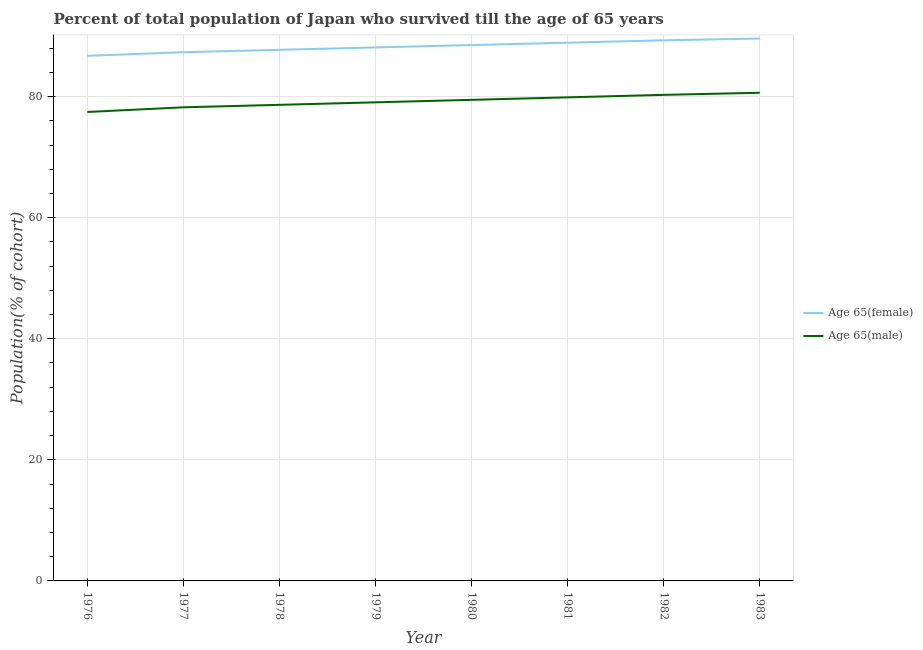How many different coloured lines are there?
Ensure brevity in your answer.  2. What is the percentage of female population who survived till age of 65 in 1976?
Provide a succinct answer. 86.73. Across all years, what is the maximum percentage of male population who survived till age of 65?
Provide a short and direct response. 80.63. Across all years, what is the minimum percentage of male population who survived till age of 65?
Keep it short and to the point. 77.46. In which year was the percentage of female population who survived till age of 65 minimum?
Your response must be concise. 1976. What is the total percentage of male population who survived till age of 65 in the graph?
Your answer should be very brief. 633.63. What is the difference between the percentage of female population who survived till age of 65 in 1980 and that in 1981?
Ensure brevity in your answer.  -0.39. What is the difference between the percentage of female population who survived till age of 65 in 1979 and the percentage of male population who survived till age of 65 in 1982?
Offer a terse response. 7.83. What is the average percentage of male population who survived till age of 65 per year?
Ensure brevity in your answer.  79.2. In the year 1979, what is the difference between the percentage of female population who survived till age of 65 and percentage of male population who survived till age of 65?
Ensure brevity in your answer.  9.07. In how many years, is the percentage of male population who survived till age of 65 greater than 8 %?
Your answer should be very brief. 8. What is the ratio of the percentage of female population who survived till age of 65 in 1979 to that in 1982?
Your answer should be compact. 0.99. What is the difference between the highest and the second highest percentage of male population who survived till age of 65?
Offer a very short reply. 0.35. What is the difference between the highest and the lowest percentage of male population who survived till age of 65?
Provide a short and direct response. 3.17. In how many years, is the percentage of female population who survived till age of 65 greater than the average percentage of female population who survived till age of 65 taken over all years?
Your response must be concise. 4. Is the sum of the percentage of female population who survived till age of 65 in 1980 and 1981 greater than the maximum percentage of male population who survived till age of 65 across all years?
Offer a terse response. Yes. Does the percentage of male population who survived till age of 65 monotonically increase over the years?
Your answer should be compact. Yes. Is the percentage of male population who survived till age of 65 strictly less than the percentage of female population who survived till age of 65 over the years?
Your answer should be compact. Yes. How many lines are there?
Your answer should be compact. 2. How many years are there in the graph?
Offer a very short reply. 8. Are the values on the major ticks of Y-axis written in scientific E-notation?
Offer a very short reply. No. How are the legend labels stacked?
Ensure brevity in your answer.  Vertical. What is the title of the graph?
Offer a terse response. Percent of total population of Japan who survived till the age of 65 years. What is the label or title of the Y-axis?
Provide a succinct answer. Population(% of cohort). What is the Population(% of cohort) of Age 65(female) in 1976?
Offer a terse response. 86.73. What is the Population(% of cohort) of Age 65(male) in 1976?
Ensure brevity in your answer.  77.46. What is the Population(% of cohort) of Age 65(female) in 1977?
Provide a short and direct response. 87.33. What is the Population(% of cohort) in Age 65(male) in 1977?
Provide a short and direct response. 78.23. What is the Population(% of cohort) of Age 65(female) in 1978?
Your response must be concise. 87.72. What is the Population(% of cohort) of Age 65(male) in 1978?
Keep it short and to the point. 78.64. What is the Population(% of cohort) of Age 65(female) in 1979?
Give a very brief answer. 88.12. What is the Population(% of cohort) of Age 65(male) in 1979?
Your answer should be compact. 79.05. What is the Population(% of cohort) of Age 65(female) in 1980?
Offer a terse response. 88.51. What is the Population(% of cohort) in Age 65(male) in 1980?
Offer a terse response. 79.46. What is the Population(% of cohort) of Age 65(female) in 1981?
Make the answer very short. 88.9. What is the Population(% of cohort) of Age 65(male) in 1981?
Your answer should be compact. 79.87. What is the Population(% of cohort) of Age 65(female) in 1982?
Provide a short and direct response. 89.3. What is the Population(% of cohort) of Age 65(male) in 1982?
Keep it short and to the point. 80.29. What is the Population(% of cohort) in Age 65(female) in 1983?
Ensure brevity in your answer.  89.59. What is the Population(% of cohort) of Age 65(male) in 1983?
Keep it short and to the point. 80.63. Across all years, what is the maximum Population(% of cohort) of Age 65(female)?
Provide a short and direct response. 89.59. Across all years, what is the maximum Population(% of cohort) of Age 65(male)?
Offer a very short reply. 80.63. Across all years, what is the minimum Population(% of cohort) in Age 65(female)?
Ensure brevity in your answer.  86.73. Across all years, what is the minimum Population(% of cohort) in Age 65(male)?
Your answer should be compact. 77.46. What is the total Population(% of cohort) of Age 65(female) in the graph?
Provide a short and direct response. 706.2. What is the total Population(% of cohort) in Age 65(male) in the graph?
Ensure brevity in your answer.  633.63. What is the difference between the Population(% of cohort) in Age 65(female) in 1976 and that in 1977?
Give a very brief answer. -0.6. What is the difference between the Population(% of cohort) of Age 65(male) in 1976 and that in 1977?
Provide a short and direct response. -0.77. What is the difference between the Population(% of cohort) of Age 65(female) in 1976 and that in 1978?
Provide a short and direct response. -1. What is the difference between the Population(% of cohort) in Age 65(male) in 1976 and that in 1978?
Your answer should be compact. -1.18. What is the difference between the Population(% of cohort) of Age 65(female) in 1976 and that in 1979?
Your answer should be very brief. -1.39. What is the difference between the Population(% of cohort) of Age 65(male) in 1976 and that in 1979?
Your answer should be very brief. -1.59. What is the difference between the Population(% of cohort) in Age 65(female) in 1976 and that in 1980?
Your answer should be very brief. -1.78. What is the difference between the Population(% of cohort) in Age 65(male) in 1976 and that in 1980?
Provide a short and direct response. -2. What is the difference between the Population(% of cohort) in Age 65(female) in 1976 and that in 1981?
Give a very brief answer. -2.18. What is the difference between the Population(% of cohort) of Age 65(male) in 1976 and that in 1981?
Keep it short and to the point. -2.42. What is the difference between the Population(% of cohort) in Age 65(female) in 1976 and that in 1982?
Your response must be concise. -2.57. What is the difference between the Population(% of cohort) of Age 65(male) in 1976 and that in 1982?
Make the answer very short. -2.83. What is the difference between the Population(% of cohort) in Age 65(female) in 1976 and that in 1983?
Your answer should be very brief. -2.86. What is the difference between the Population(% of cohort) in Age 65(male) in 1976 and that in 1983?
Your answer should be very brief. -3.17. What is the difference between the Population(% of cohort) of Age 65(female) in 1977 and that in 1978?
Keep it short and to the point. -0.39. What is the difference between the Population(% of cohort) in Age 65(male) in 1977 and that in 1978?
Provide a short and direct response. -0.41. What is the difference between the Population(% of cohort) of Age 65(female) in 1977 and that in 1979?
Provide a short and direct response. -0.79. What is the difference between the Population(% of cohort) in Age 65(male) in 1977 and that in 1979?
Give a very brief answer. -0.82. What is the difference between the Population(% of cohort) of Age 65(female) in 1977 and that in 1980?
Your answer should be very brief. -1.18. What is the difference between the Population(% of cohort) in Age 65(male) in 1977 and that in 1980?
Give a very brief answer. -1.24. What is the difference between the Population(% of cohort) of Age 65(female) in 1977 and that in 1981?
Your answer should be very brief. -1.57. What is the difference between the Population(% of cohort) of Age 65(male) in 1977 and that in 1981?
Give a very brief answer. -1.65. What is the difference between the Population(% of cohort) of Age 65(female) in 1977 and that in 1982?
Make the answer very short. -1.97. What is the difference between the Population(% of cohort) in Age 65(male) in 1977 and that in 1982?
Your answer should be very brief. -2.06. What is the difference between the Population(% of cohort) of Age 65(female) in 1977 and that in 1983?
Your answer should be compact. -2.25. What is the difference between the Population(% of cohort) in Age 65(male) in 1977 and that in 1983?
Provide a succinct answer. -2.41. What is the difference between the Population(% of cohort) in Age 65(female) in 1978 and that in 1979?
Your answer should be very brief. -0.39. What is the difference between the Population(% of cohort) of Age 65(male) in 1978 and that in 1979?
Make the answer very short. -0.41. What is the difference between the Population(% of cohort) of Age 65(female) in 1978 and that in 1980?
Your answer should be very brief. -0.79. What is the difference between the Population(% of cohort) in Age 65(male) in 1978 and that in 1980?
Your answer should be very brief. -0.82. What is the difference between the Population(% of cohort) of Age 65(female) in 1978 and that in 1981?
Offer a terse response. -1.18. What is the difference between the Population(% of cohort) in Age 65(male) in 1978 and that in 1981?
Offer a very short reply. -1.24. What is the difference between the Population(% of cohort) in Age 65(female) in 1978 and that in 1982?
Provide a succinct answer. -1.57. What is the difference between the Population(% of cohort) in Age 65(male) in 1978 and that in 1982?
Your response must be concise. -1.65. What is the difference between the Population(% of cohort) in Age 65(female) in 1978 and that in 1983?
Offer a very short reply. -1.86. What is the difference between the Population(% of cohort) of Age 65(male) in 1978 and that in 1983?
Keep it short and to the point. -2. What is the difference between the Population(% of cohort) of Age 65(female) in 1979 and that in 1980?
Your answer should be compact. -0.39. What is the difference between the Population(% of cohort) of Age 65(male) in 1979 and that in 1980?
Provide a short and direct response. -0.41. What is the difference between the Population(% of cohort) in Age 65(female) in 1979 and that in 1981?
Provide a succinct answer. -0.79. What is the difference between the Population(% of cohort) of Age 65(male) in 1979 and that in 1981?
Your answer should be very brief. -0.82. What is the difference between the Population(% of cohort) of Age 65(female) in 1979 and that in 1982?
Your response must be concise. -1.18. What is the difference between the Population(% of cohort) in Age 65(male) in 1979 and that in 1982?
Offer a terse response. -1.24. What is the difference between the Population(% of cohort) of Age 65(female) in 1979 and that in 1983?
Your answer should be compact. -1.47. What is the difference between the Population(% of cohort) of Age 65(male) in 1979 and that in 1983?
Provide a short and direct response. -1.58. What is the difference between the Population(% of cohort) of Age 65(female) in 1980 and that in 1981?
Provide a succinct answer. -0.39. What is the difference between the Population(% of cohort) of Age 65(male) in 1980 and that in 1981?
Give a very brief answer. -0.41. What is the difference between the Population(% of cohort) in Age 65(female) in 1980 and that in 1982?
Make the answer very short. -0.79. What is the difference between the Population(% of cohort) of Age 65(male) in 1980 and that in 1982?
Your response must be concise. -0.82. What is the difference between the Population(% of cohort) of Age 65(female) in 1980 and that in 1983?
Make the answer very short. -1.07. What is the difference between the Population(% of cohort) in Age 65(male) in 1980 and that in 1983?
Your answer should be very brief. -1.17. What is the difference between the Population(% of cohort) of Age 65(female) in 1981 and that in 1982?
Offer a terse response. -0.39. What is the difference between the Population(% of cohort) of Age 65(male) in 1981 and that in 1982?
Your response must be concise. -0.41. What is the difference between the Population(% of cohort) of Age 65(female) in 1981 and that in 1983?
Offer a terse response. -0.68. What is the difference between the Population(% of cohort) of Age 65(male) in 1981 and that in 1983?
Offer a very short reply. -0.76. What is the difference between the Population(% of cohort) of Age 65(female) in 1982 and that in 1983?
Ensure brevity in your answer.  -0.29. What is the difference between the Population(% of cohort) of Age 65(male) in 1982 and that in 1983?
Your answer should be compact. -0.35. What is the difference between the Population(% of cohort) of Age 65(female) in 1976 and the Population(% of cohort) of Age 65(male) in 1977?
Ensure brevity in your answer.  8.5. What is the difference between the Population(% of cohort) of Age 65(female) in 1976 and the Population(% of cohort) of Age 65(male) in 1978?
Give a very brief answer. 8.09. What is the difference between the Population(% of cohort) in Age 65(female) in 1976 and the Population(% of cohort) in Age 65(male) in 1979?
Your response must be concise. 7.68. What is the difference between the Population(% of cohort) of Age 65(female) in 1976 and the Population(% of cohort) of Age 65(male) in 1980?
Your answer should be compact. 7.27. What is the difference between the Population(% of cohort) of Age 65(female) in 1976 and the Population(% of cohort) of Age 65(male) in 1981?
Ensure brevity in your answer.  6.85. What is the difference between the Population(% of cohort) of Age 65(female) in 1976 and the Population(% of cohort) of Age 65(male) in 1982?
Your answer should be compact. 6.44. What is the difference between the Population(% of cohort) in Age 65(female) in 1976 and the Population(% of cohort) in Age 65(male) in 1983?
Keep it short and to the point. 6.09. What is the difference between the Population(% of cohort) in Age 65(female) in 1977 and the Population(% of cohort) in Age 65(male) in 1978?
Provide a succinct answer. 8.69. What is the difference between the Population(% of cohort) of Age 65(female) in 1977 and the Population(% of cohort) of Age 65(male) in 1979?
Offer a terse response. 8.28. What is the difference between the Population(% of cohort) of Age 65(female) in 1977 and the Population(% of cohort) of Age 65(male) in 1980?
Your answer should be very brief. 7.87. What is the difference between the Population(% of cohort) of Age 65(female) in 1977 and the Population(% of cohort) of Age 65(male) in 1981?
Offer a terse response. 7.46. What is the difference between the Population(% of cohort) in Age 65(female) in 1977 and the Population(% of cohort) in Age 65(male) in 1982?
Provide a short and direct response. 7.05. What is the difference between the Population(% of cohort) of Age 65(female) in 1977 and the Population(% of cohort) of Age 65(male) in 1983?
Keep it short and to the point. 6.7. What is the difference between the Population(% of cohort) in Age 65(female) in 1978 and the Population(% of cohort) in Age 65(male) in 1979?
Offer a terse response. 8.67. What is the difference between the Population(% of cohort) of Age 65(female) in 1978 and the Population(% of cohort) of Age 65(male) in 1980?
Offer a very short reply. 8.26. What is the difference between the Population(% of cohort) of Age 65(female) in 1978 and the Population(% of cohort) of Age 65(male) in 1981?
Offer a terse response. 7.85. What is the difference between the Population(% of cohort) of Age 65(female) in 1978 and the Population(% of cohort) of Age 65(male) in 1982?
Your answer should be compact. 7.44. What is the difference between the Population(% of cohort) in Age 65(female) in 1978 and the Population(% of cohort) in Age 65(male) in 1983?
Ensure brevity in your answer.  7.09. What is the difference between the Population(% of cohort) in Age 65(female) in 1979 and the Population(% of cohort) in Age 65(male) in 1980?
Offer a very short reply. 8.66. What is the difference between the Population(% of cohort) of Age 65(female) in 1979 and the Population(% of cohort) of Age 65(male) in 1981?
Ensure brevity in your answer.  8.24. What is the difference between the Population(% of cohort) in Age 65(female) in 1979 and the Population(% of cohort) in Age 65(male) in 1982?
Your answer should be very brief. 7.83. What is the difference between the Population(% of cohort) of Age 65(female) in 1979 and the Population(% of cohort) of Age 65(male) in 1983?
Your answer should be compact. 7.48. What is the difference between the Population(% of cohort) in Age 65(female) in 1980 and the Population(% of cohort) in Age 65(male) in 1981?
Make the answer very short. 8.64. What is the difference between the Population(% of cohort) of Age 65(female) in 1980 and the Population(% of cohort) of Age 65(male) in 1982?
Ensure brevity in your answer.  8.23. What is the difference between the Population(% of cohort) in Age 65(female) in 1980 and the Population(% of cohort) in Age 65(male) in 1983?
Ensure brevity in your answer.  7.88. What is the difference between the Population(% of cohort) in Age 65(female) in 1981 and the Population(% of cohort) in Age 65(male) in 1982?
Offer a very short reply. 8.62. What is the difference between the Population(% of cohort) in Age 65(female) in 1981 and the Population(% of cohort) in Age 65(male) in 1983?
Provide a succinct answer. 8.27. What is the difference between the Population(% of cohort) in Age 65(female) in 1982 and the Population(% of cohort) in Age 65(male) in 1983?
Your answer should be very brief. 8.66. What is the average Population(% of cohort) in Age 65(female) per year?
Your answer should be compact. 88.28. What is the average Population(% of cohort) of Age 65(male) per year?
Your answer should be very brief. 79.2. In the year 1976, what is the difference between the Population(% of cohort) of Age 65(female) and Population(% of cohort) of Age 65(male)?
Provide a short and direct response. 9.27. In the year 1977, what is the difference between the Population(% of cohort) in Age 65(female) and Population(% of cohort) in Age 65(male)?
Provide a short and direct response. 9.1. In the year 1978, what is the difference between the Population(% of cohort) of Age 65(female) and Population(% of cohort) of Age 65(male)?
Offer a very short reply. 9.09. In the year 1979, what is the difference between the Population(% of cohort) of Age 65(female) and Population(% of cohort) of Age 65(male)?
Offer a terse response. 9.07. In the year 1980, what is the difference between the Population(% of cohort) of Age 65(female) and Population(% of cohort) of Age 65(male)?
Offer a very short reply. 9.05. In the year 1981, what is the difference between the Population(% of cohort) in Age 65(female) and Population(% of cohort) in Age 65(male)?
Give a very brief answer. 9.03. In the year 1982, what is the difference between the Population(% of cohort) in Age 65(female) and Population(% of cohort) in Age 65(male)?
Provide a succinct answer. 9.01. In the year 1983, what is the difference between the Population(% of cohort) in Age 65(female) and Population(% of cohort) in Age 65(male)?
Provide a succinct answer. 8.95. What is the ratio of the Population(% of cohort) of Age 65(female) in 1976 to that in 1977?
Offer a terse response. 0.99. What is the ratio of the Population(% of cohort) in Age 65(male) in 1976 to that in 1977?
Provide a short and direct response. 0.99. What is the ratio of the Population(% of cohort) of Age 65(male) in 1976 to that in 1978?
Ensure brevity in your answer.  0.98. What is the ratio of the Population(% of cohort) in Age 65(female) in 1976 to that in 1979?
Ensure brevity in your answer.  0.98. What is the ratio of the Population(% of cohort) of Age 65(male) in 1976 to that in 1979?
Your answer should be compact. 0.98. What is the ratio of the Population(% of cohort) in Age 65(female) in 1976 to that in 1980?
Your answer should be very brief. 0.98. What is the ratio of the Population(% of cohort) of Age 65(male) in 1976 to that in 1980?
Offer a very short reply. 0.97. What is the ratio of the Population(% of cohort) of Age 65(female) in 1976 to that in 1981?
Provide a succinct answer. 0.98. What is the ratio of the Population(% of cohort) of Age 65(male) in 1976 to that in 1981?
Ensure brevity in your answer.  0.97. What is the ratio of the Population(% of cohort) of Age 65(female) in 1976 to that in 1982?
Give a very brief answer. 0.97. What is the ratio of the Population(% of cohort) in Age 65(male) in 1976 to that in 1982?
Ensure brevity in your answer.  0.96. What is the ratio of the Population(% of cohort) of Age 65(female) in 1976 to that in 1983?
Provide a short and direct response. 0.97. What is the ratio of the Population(% of cohort) of Age 65(male) in 1976 to that in 1983?
Your answer should be very brief. 0.96. What is the ratio of the Population(% of cohort) in Age 65(female) in 1977 to that in 1978?
Keep it short and to the point. 1. What is the ratio of the Population(% of cohort) of Age 65(male) in 1977 to that in 1978?
Offer a very short reply. 0.99. What is the ratio of the Population(% of cohort) in Age 65(female) in 1977 to that in 1979?
Offer a terse response. 0.99. What is the ratio of the Population(% of cohort) in Age 65(female) in 1977 to that in 1980?
Provide a short and direct response. 0.99. What is the ratio of the Population(% of cohort) in Age 65(male) in 1977 to that in 1980?
Ensure brevity in your answer.  0.98. What is the ratio of the Population(% of cohort) in Age 65(female) in 1977 to that in 1981?
Ensure brevity in your answer.  0.98. What is the ratio of the Population(% of cohort) in Age 65(male) in 1977 to that in 1981?
Your answer should be compact. 0.98. What is the ratio of the Population(% of cohort) of Age 65(female) in 1977 to that in 1982?
Offer a terse response. 0.98. What is the ratio of the Population(% of cohort) of Age 65(male) in 1977 to that in 1982?
Offer a very short reply. 0.97. What is the ratio of the Population(% of cohort) in Age 65(female) in 1977 to that in 1983?
Your answer should be very brief. 0.97. What is the ratio of the Population(% of cohort) in Age 65(male) in 1977 to that in 1983?
Your response must be concise. 0.97. What is the ratio of the Population(% of cohort) of Age 65(female) in 1978 to that in 1979?
Your answer should be very brief. 1. What is the ratio of the Population(% of cohort) in Age 65(male) in 1978 to that in 1979?
Offer a very short reply. 0.99. What is the ratio of the Population(% of cohort) in Age 65(female) in 1978 to that in 1980?
Ensure brevity in your answer.  0.99. What is the ratio of the Population(% of cohort) of Age 65(female) in 1978 to that in 1981?
Your response must be concise. 0.99. What is the ratio of the Population(% of cohort) in Age 65(male) in 1978 to that in 1981?
Provide a succinct answer. 0.98. What is the ratio of the Population(% of cohort) in Age 65(female) in 1978 to that in 1982?
Offer a very short reply. 0.98. What is the ratio of the Population(% of cohort) of Age 65(male) in 1978 to that in 1982?
Offer a very short reply. 0.98. What is the ratio of the Population(% of cohort) of Age 65(female) in 1978 to that in 1983?
Provide a short and direct response. 0.98. What is the ratio of the Population(% of cohort) in Age 65(male) in 1978 to that in 1983?
Make the answer very short. 0.98. What is the ratio of the Population(% of cohort) of Age 65(male) in 1979 to that in 1982?
Give a very brief answer. 0.98. What is the ratio of the Population(% of cohort) of Age 65(female) in 1979 to that in 1983?
Make the answer very short. 0.98. What is the ratio of the Population(% of cohort) of Age 65(male) in 1979 to that in 1983?
Offer a terse response. 0.98. What is the ratio of the Population(% of cohort) of Age 65(female) in 1980 to that in 1981?
Keep it short and to the point. 1. What is the ratio of the Population(% of cohort) in Age 65(male) in 1980 to that in 1981?
Your answer should be very brief. 0.99. What is the ratio of the Population(% of cohort) in Age 65(female) in 1980 to that in 1982?
Make the answer very short. 0.99. What is the ratio of the Population(% of cohort) in Age 65(male) in 1980 to that in 1982?
Your answer should be compact. 0.99. What is the ratio of the Population(% of cohort) in Age 65(male) in 1980 to that in 1983?
Give a very brief answer. 0.99. What is the ratio of the Population(% of cohort) in Age 65(female) in 1981 to that in 1982?
Offer a terse response. 1. What is the ratio of the Population(% of cohort) in Age 65(male) in 1981 to that in 1982?
Your response must be concise. 0.99. What is the ratio of the Population(% of cohort) in Age 65(male) in 1981 to that in 1983?
Your answer should be compact. 0.99. What is the ratio of the Population(% of cohort) of Age 65(female) in 1982 to that in 1983?
Provide a succinct answer. 1. What is the difference between the highest and the second highest Population(% of cohort) in Age 65(female)?
Provide a short and direct response. 0.29. What is the difference between the highest and the second highest Population(% of cohort) in Age 65(male)?
Keep it short and to the point. 0.35. What is the difference between the highest and the lowest Population(% of cohort) of Age 65(female)?
Provide a succinct answer. 2.86. What is the difference between the highest and the lowest Population(% of cohort) of Age 65(male)?
Offer a very short reply. 3.17. 